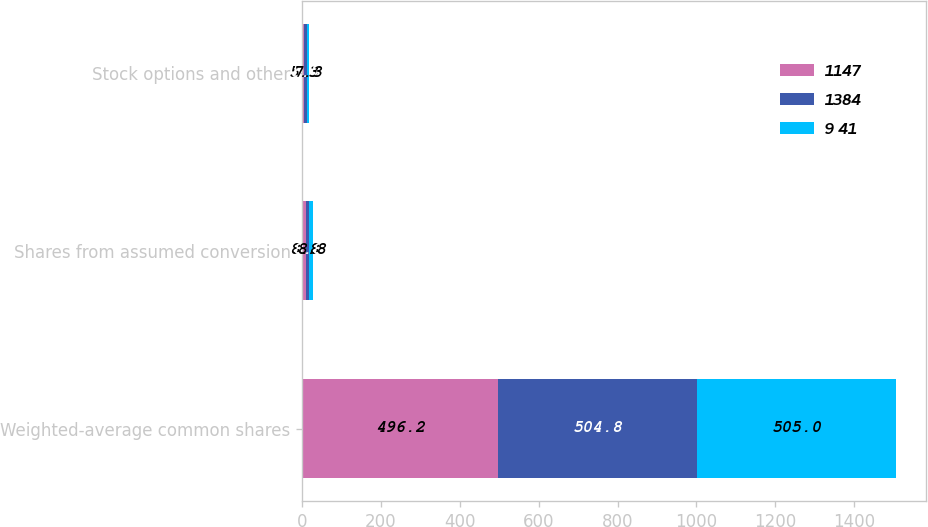Convert chart. <chart><loc_0><loc_0><loc_500><loc_500><stacked_bar_chart><ecel><fcel>Weighted-average common shares<fcel>Shares from assumed conversion<fcel>Stock options and other<nl><fcel>1147<fcel>496.2<fcel>8.8<fcel>5.3<nl><fcel>1384<fcel>504.8<fcel>8.8<fcel>5.7<nl><fcel>9 41<fcel>505<fcel>8.8<fcel>7.3<nl></chart> 